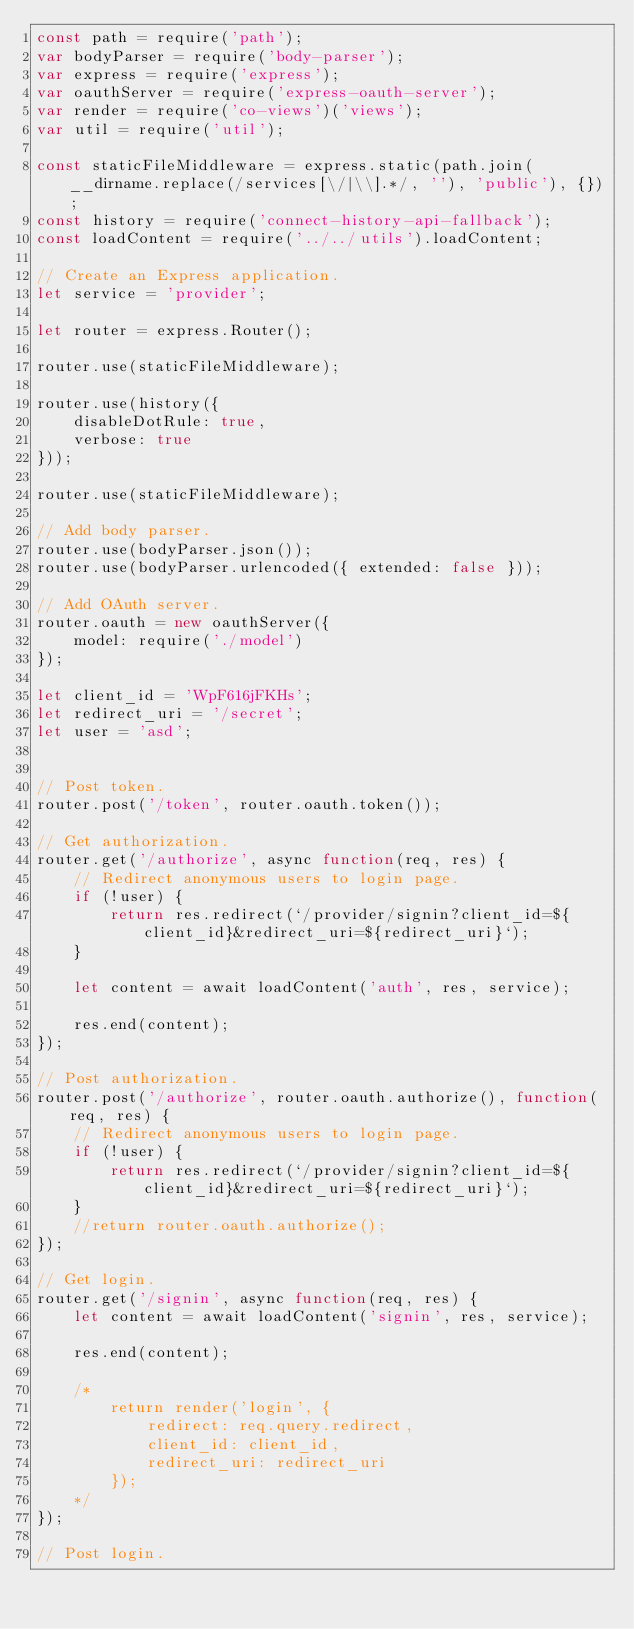<code> <loc_0><loc_0><loc_500><loc_500><_JavaScript_>const path = require('path');
var bodyParser = require('body-parser');
var express = require('express');
var oauthServer = require('express-oauth-server');
var render = require('co-views')('views');
var util = require('util');

const staticFileMiddleware = express.static(path.join(__dirname.replace(/services[\/|\\].*/, ''), 'public'), {});
const history = require('connect-history-api-fallback');
const loadContent = require('../../utils').loadContent;

// Create an Express application.
let service = 'provider';

let router = express.Router();

router.use(staticFileMiddleware);

router.use(history({
    disableDotRule: true,
    verbose: true
}));

router.use(staticFileMiddleware);

// Add body parser.
router.use(bodyParser.json());
router.use(bodyParser.urlencoded({ extended: false }));

// Add OAuth server.
router.oauth = new oauthServer({
    model: require('./model')
});

let client_id = 'WpF616jFKHs';
let redirect_uri = '/secret';
let user = 'asd';


// Post token.
router.post('/token', router.oauth.token());

// Get authorization.
router.get('/authorize', async function(req, res) {
    // Redirect anonymous users to login page.
    if (!user) {
        return res.redirect(`/provider/signin?client_id=${client_id}&redirect_uri=${redirect_uri}`);
    }

    let content = await loadContent('auth', res, service);

    res.end(content);
});

// Post authorization.
router.post('/authorize', router.oauth.authorize(), function(req, res) {
    // Redirect anonymous users to login page.
    if (!user) {
        return res.redirect(`/provider/signin?client_id=${client_id}&redirect_uri=${redirect_uri}`);
    }
    //return router.oauth.authorize();
});

// Get login.
router.get('/signin', async function(req, res) {
    let content = await loadContent('signin', res, service);

    res.end(content);

    /*
        return render('login', {
            redirect: req.query.redirect,
            client_id: client_id,
            redirect_uri: redirect_uri
        });
    */
});

// Post login.</code> 